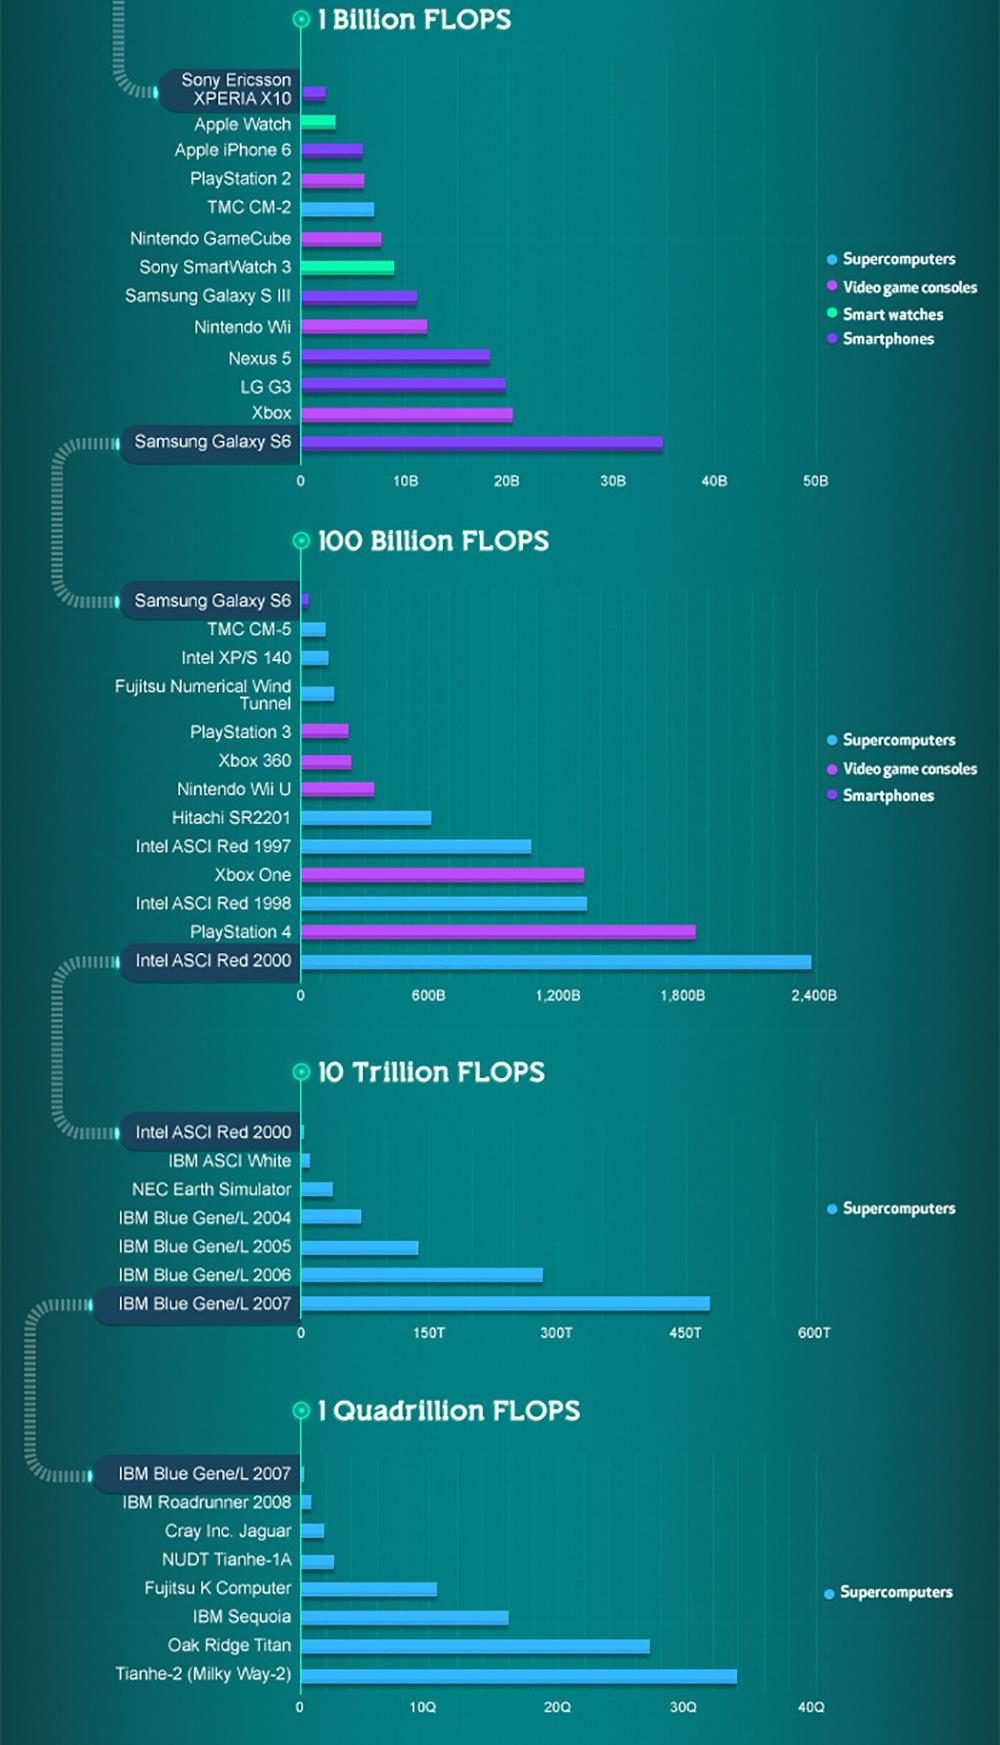List a handful of essential elements in this visual. The color used to represent smart watches is green. The measure of computer performance is referred to as FLOPS. 